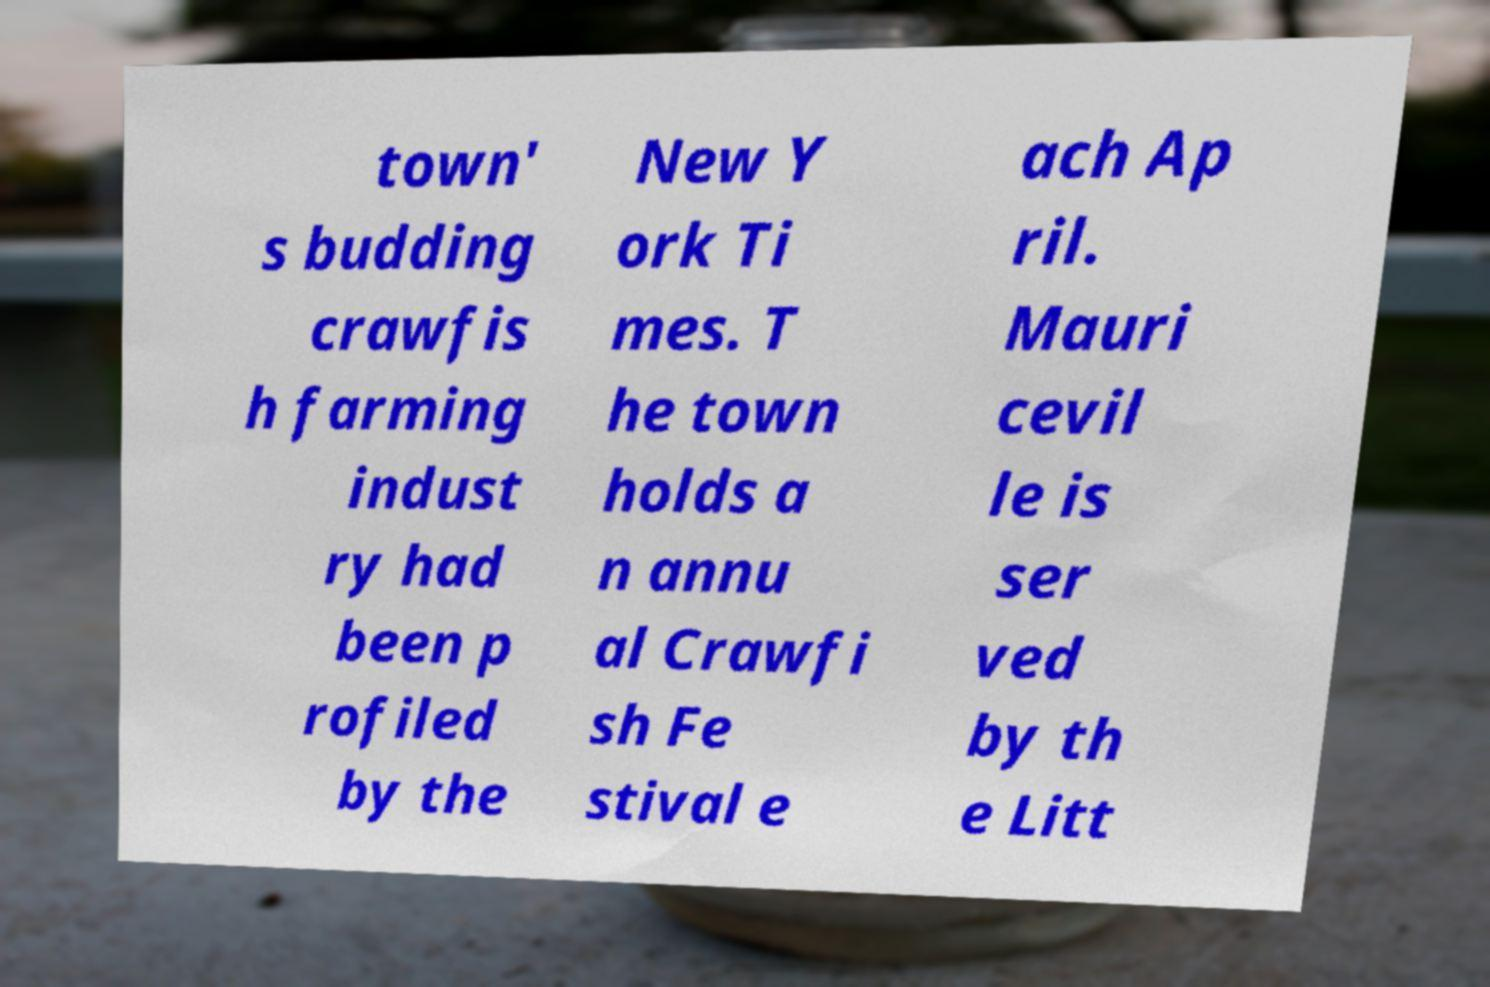Please read and relay the text visible in this image. What does it say? town' s budding crawfis h farming indust ry had been p rofiled by the New Y ork Ti mes. T he town holds a n annu al Crawfi sh Fe stival e ach Ap ril. Mauri cevil le is ser ved by th e Litt 